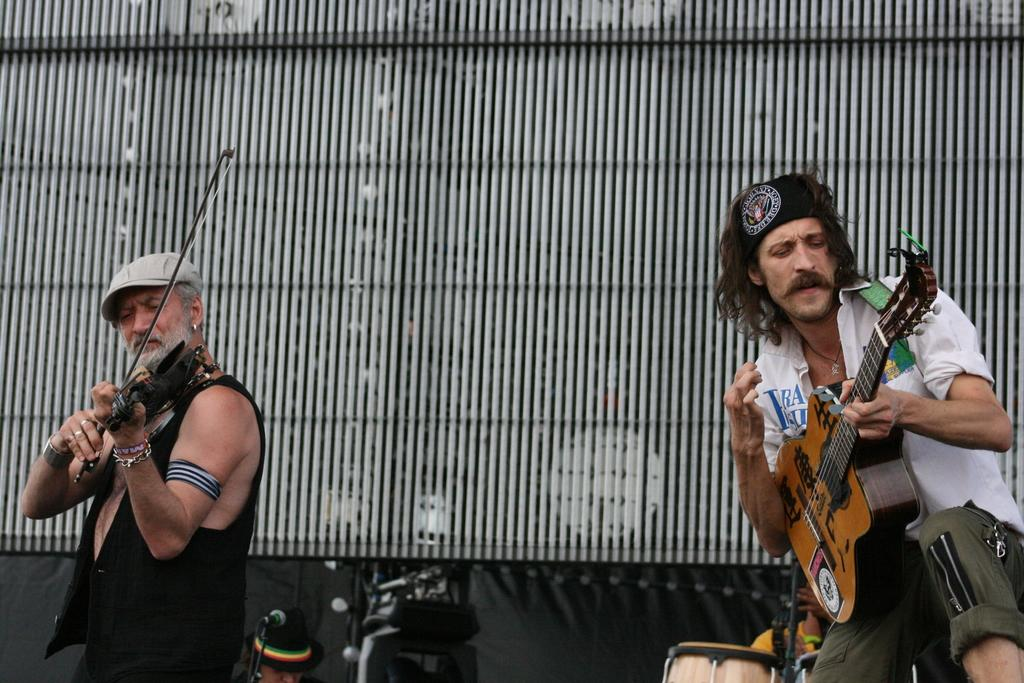How many people are in the image? There are two old men in the image. What are the old men doing in the image? The old men are playing guitar. What other musical instrument can be seen in the background of the image? There is a drum kit in the background of the image. What part of the world's history is depicted in the image? The image does not depict any specific part of world history; it features two old men playing guitar and a drum kit in the background. 